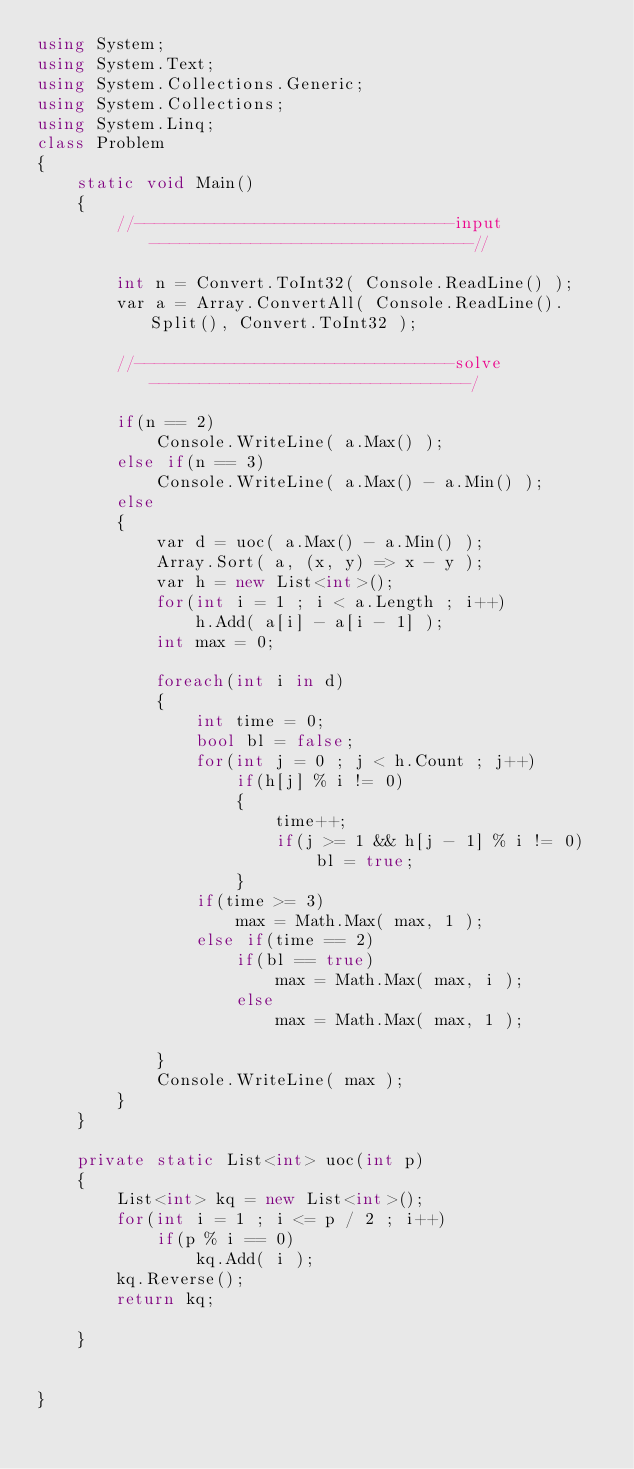Convert code to text. <code><loc_0><loc_0><loc_500><loc_500><_C#_>using System;
using System.Text;
using System.Collections.Generic;
using System.Collections;
using System.Linq;
class Problem
{
    static void Main()
    {
        //--------------------------------input--------------------------------//

        int n = Convert.ToInt32( Console.ReadLine() );
        var a = Array.ConvertAll( Console.ReadLine().Split(), Convert.ToInt32 );

        //--------------------------------solve--------------------------------/

        if(n == 2)
            Console.WriteLine( a.Max() );
        else if(n == 3)
            Console.WriteLine( a.Max() - a.Min() );
        else
        {
            var d = uoc( a.Max() - a.Min() );
            Array.Sort( a, (x, y) => x - y );
            var h = new List<int>();
            for(int i = 1 ; i < a.Length ; i++)
                h.Add( a[i] - a[i - 1] );
            int max = 0;

            foreach(int i in d)
            {
                int time = 0;
                bool bl = false;
                for(int j = 0 ; j < h.Count ; j++)
                    if(h[j] % i != 0)
                    {
                        time++;
                        if(j >= 1 && h[j - 1] % i != 0)
                            bl = true;
                    }
                if(time >= 3)
                    max = Math.Max( max, 1 );
                else if(time == 2)
                    if(bl == true)
                        max = Math.Max( max, i );
                    else
                        max = Math.Max( max, 1 );

            }
            Console.WriteLine( max );
        }
    }

    private static List<int> uoc(int p)
    {
        List<int> kq = new List<int>();
        for(int i = 1 ; i <= p / 2 ; i++)
            if(p % i == 0)
                kq.Add( i );
        kq.Reverse();
        return kq;

    }


}</code> 